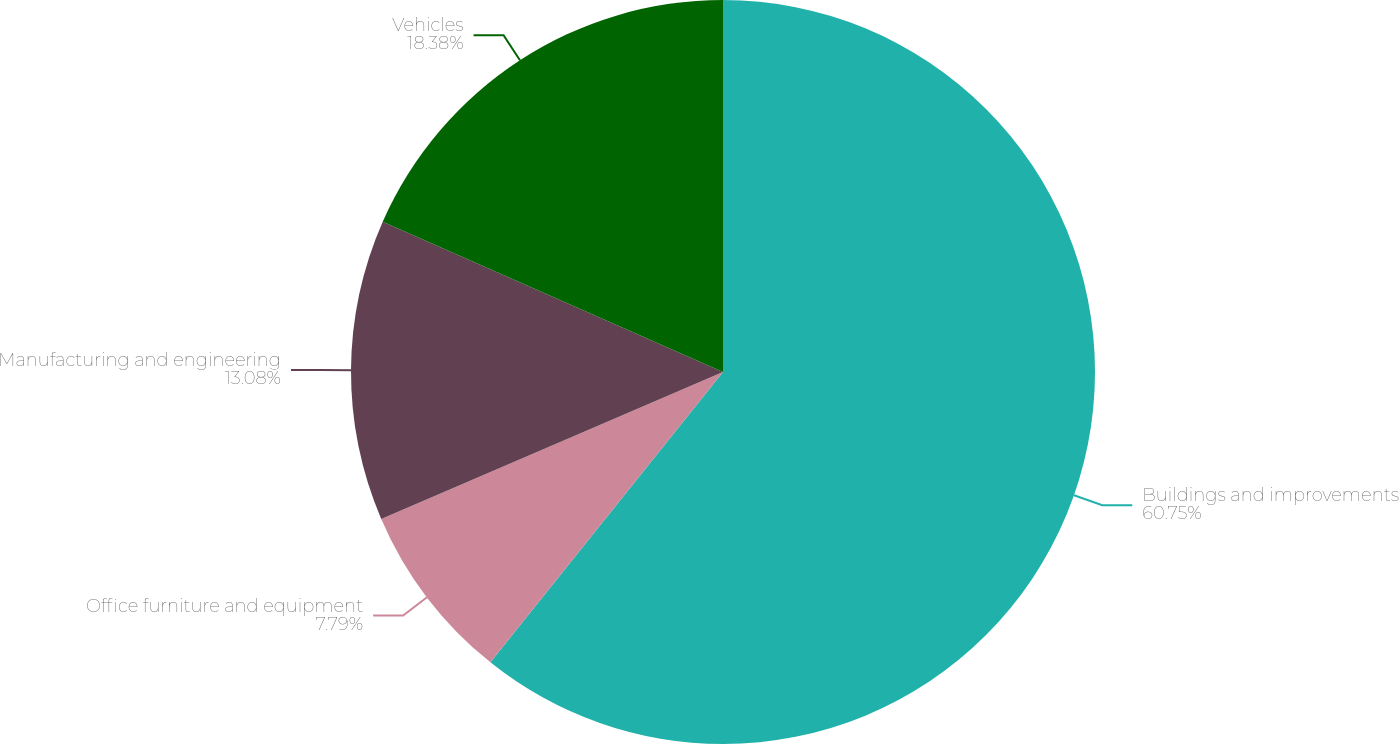Convert chart. <chart><loc_0><loc_0><loc_500><loc_500><pie_chart><fcel>Buildings and improvements<fcel>Office furniture and equipment<fcel>Manufacturing and engineering<fcel>Vehicles<nl><fcel>60.75%<fcel>7.79%<fcel>13.08%<fcel>18.38%<nl></chart> 